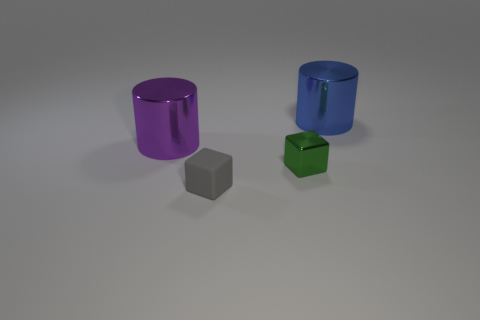The other cylinder that is made of the same material as the large blue cylinder is what size?
Your answer should be very brief. Large. Are there any other things that are the same color as the tiny matte thing?
Your answer should be very brief. No. There is a cylinder that is left of the green object that is to the right of the small rubber object in front of the big purple thing; what is it made of?
Make the answer very short. Metal. How many metal things are cylinders or cubes?
Offer a very short reply. 3. Do the tiny metallic block and the rubber thing have the same color?
Your answer should be compact. No. Is there anything else that is made of the same material as the purple cylinder?
Ensure brevity in your answer.  Yes. What number of things are cyan matte blocks or things that are to the left of the large blue object?
Offer a very short reply. 3. Do the metal object to the left of the rubber object and the large blue cylinder have the same size?
Keep it short and to the point. Yes. What number of other things are there of the same shape as the small gray thing?
Your answer should be compact. 1. What number of brown things are either metal objects or metal blocks?
Provide a succinct answer. 0. 